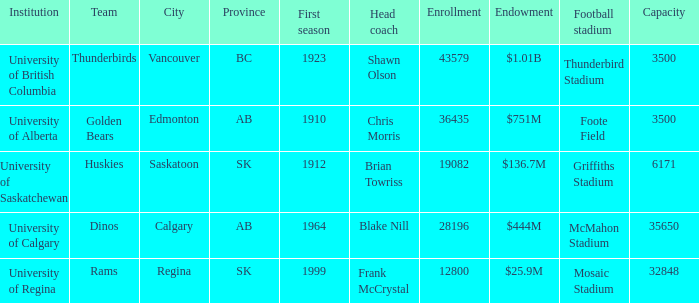What football stadium has a school enrollment of 43579? Thunderbird Stadium. 